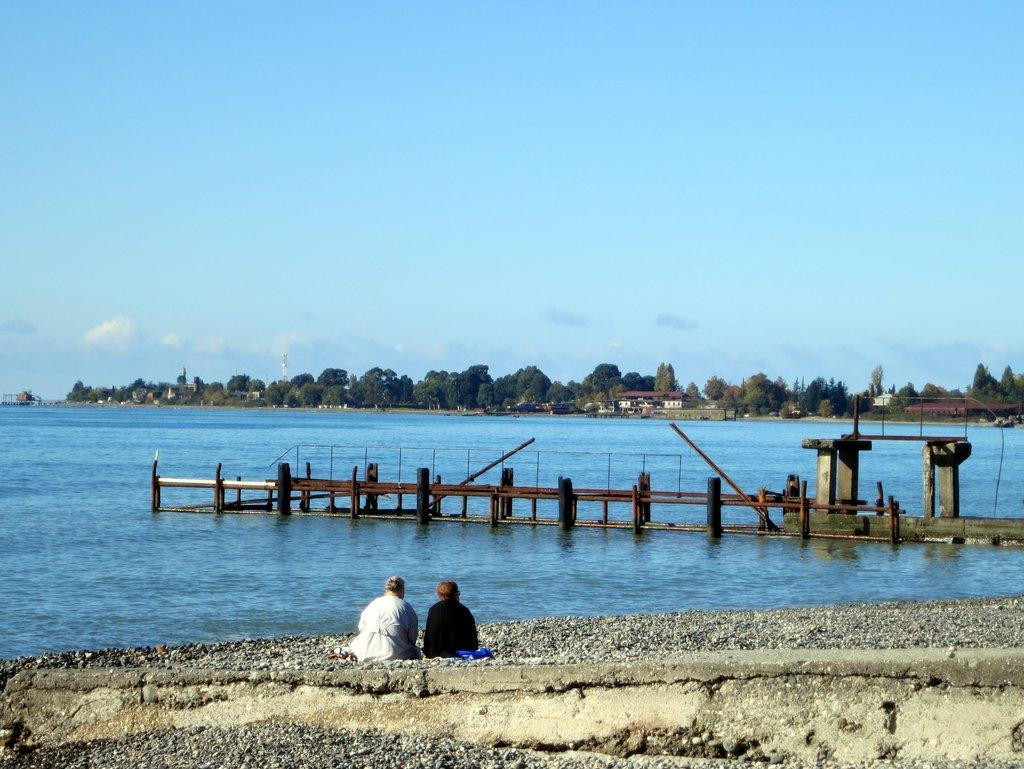What are the people in the image doing? The persons in the image are sitting on the ground. What structure can be seen in the image? There is a walkway bridge in the image. What natural element is visible in the image? There is water visible in the image. What type of vegetation is present in the image? There are trees in the image. What man-made structures can be seen in the image? There are buildings in the image. What is visible in the sky in the image? The sky with clouds can be seen in the image. Where is the scarecrow located in the image? There is no scarecrow present in the image. How many geese are swimming in the water in the image? There are no geese visible in the image; only water is present. 